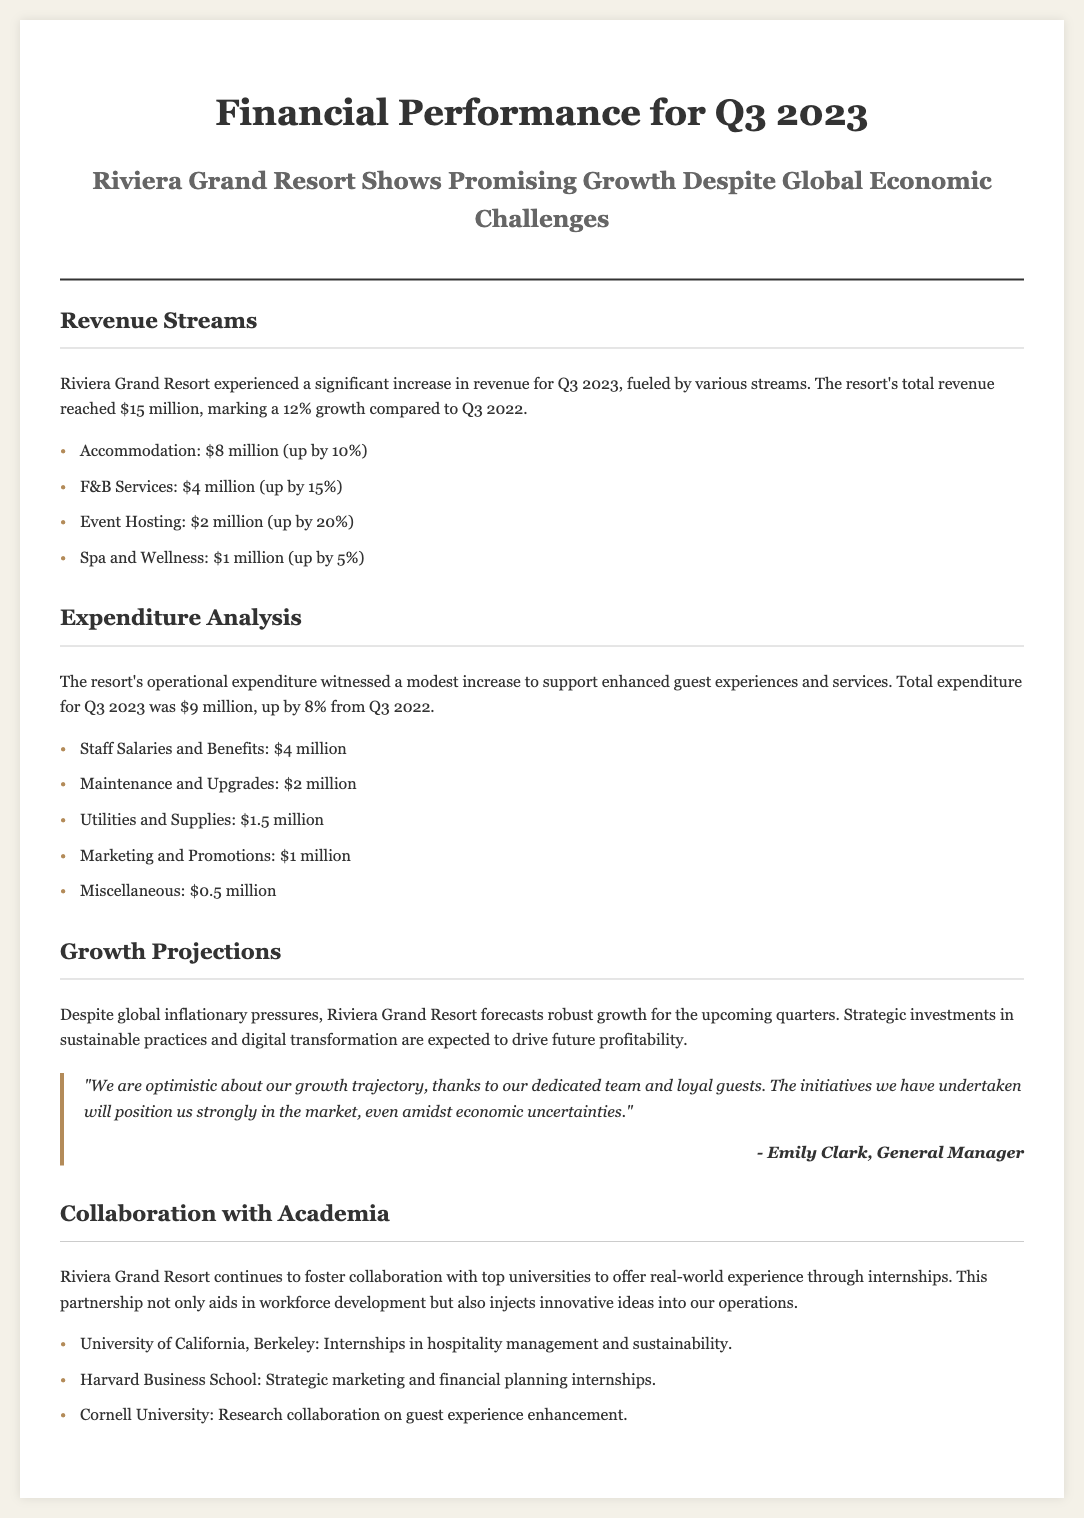what is the total revenue for Q3 2023? The total revenue for Q3 2023 is stated in the document as $15 million.
Answer: $15 million how much did the Accommodation revenue increase by? The document mentions that the Accommodation revenue increased by 10%.
Answer: 10% what was the total expenditure for Q3 2023? The total expenditure is specifically mentioned in the document as $9 million.
Answer: $9 million which revenue stream had the highest growth percentage? The document indicates that Event Hosting had the highest growth percentage at 20%.
Answer: 20% who is the General Manager of Riviera Grand Resort? The document attributes a quote to Emily Clark, who is identified as the General Manager.
Answer: Emily Clark which university is collaborating for hospitality management internships? The document lists the University of California, Berkeley for hospitality management internships.
Answer: University of California, Berkeley what is the operational expenditure increase percentage for Q3 2023? The document indicates that the operational expenditure witnessed an increase of 8%.
Answer: 8% what specific investment strategies are mentioned for future growth? The document mentions strategic investments in sustainable practices and digital transformation.
Answer: sustainable practices and digital transformation how many main categories of revenue streams are listed? The document lists a total of four main categories of revenue streams.
Answer: four 